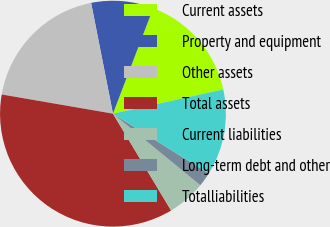Convert chart. <chart><loc_0><loc_0><loc_500><loc_500><pie_chart><fcel>Current assets<fcel>Property and equipment<fcel>Other assets<fcel>Total assets<fcel>Current liabilities<fcel>Long-term debt and other<fcel>Totalliabilities<nl><fcel>15.76%<fcel>8.9%<fcel>19.18%<fcel>36.33%<fcel>5.47%<fcel>2.04%<fcel>12.33%<nl></chart> 